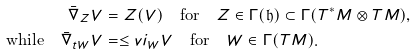Convert formula to latex. <formula><loc_0><loc_0><loc_500><loc_500>\bar { \nabla } _ { Z } V & = Z ( V ) \quad \text {for} \quad Z \in \Gamma ( { \mathfrak h } ) \subset \Gamma ( T ^ { * } M \otimes T M ) , \\ \text {while} \quad \bar { \nabla } _ { t W } V & = \leq v i _ { W } V \quad \text {for} \quad W \in \Gamma ( T M ) .</formula> 